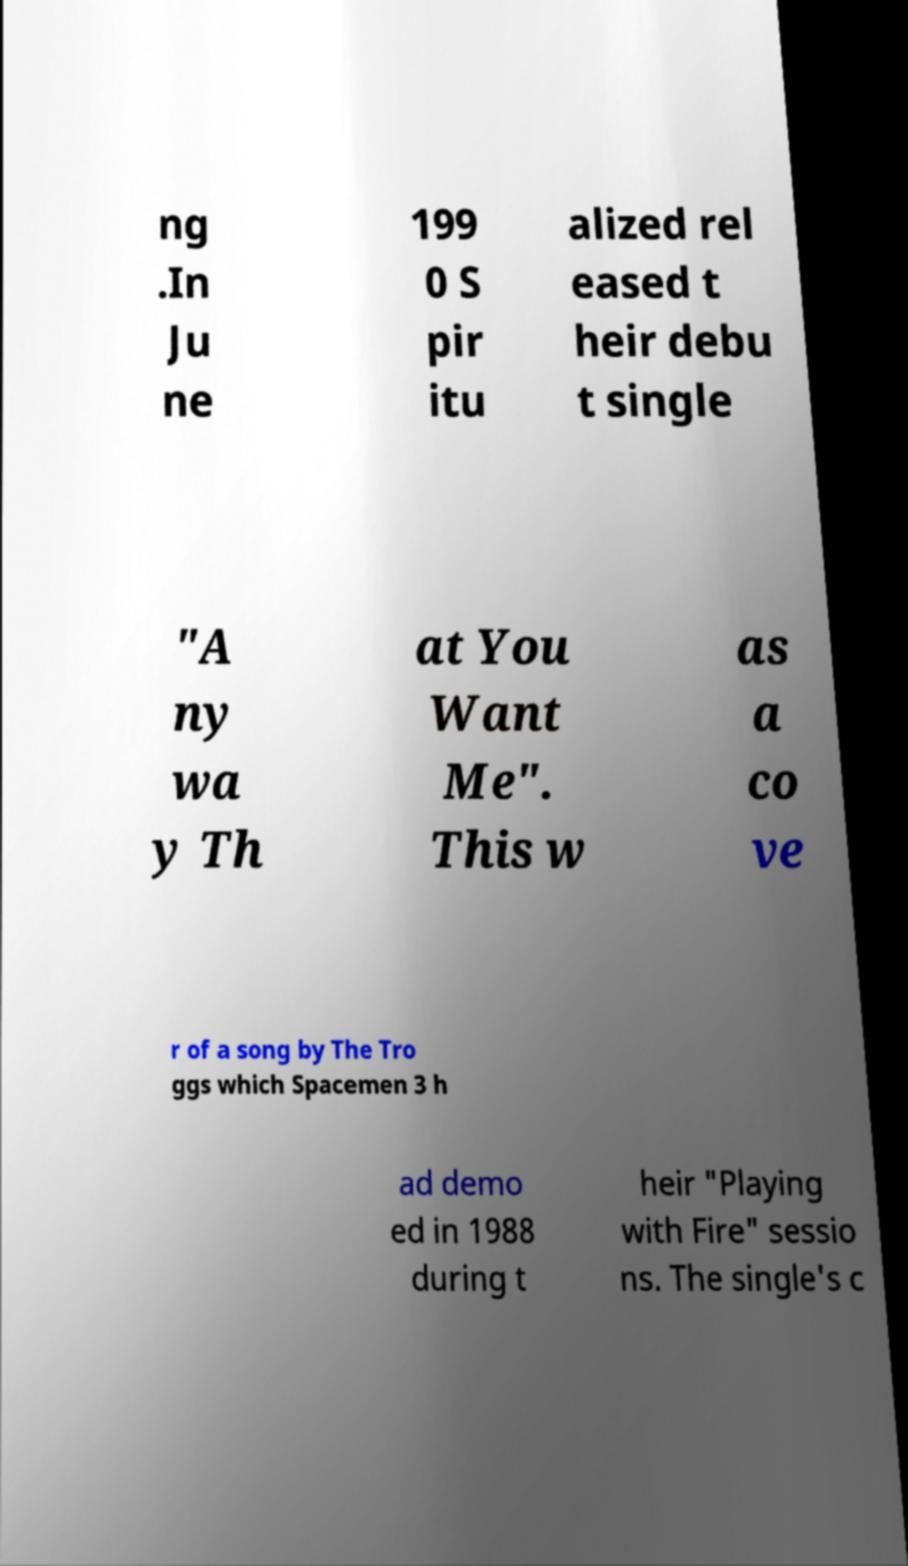There's text embedded in this image that I need extracted. Can you transcribe it verbatim? ng .In Ju ne 199 0 S pir itu alized rel eased t heir debu t single "A ny wa y Th at You Want Me". This w as a co ve r of a song by The Tro ggs which Spacemen 3 h ad demo ed in 1988 during t heir "Playing with Fire" sessio ns. The single's c 